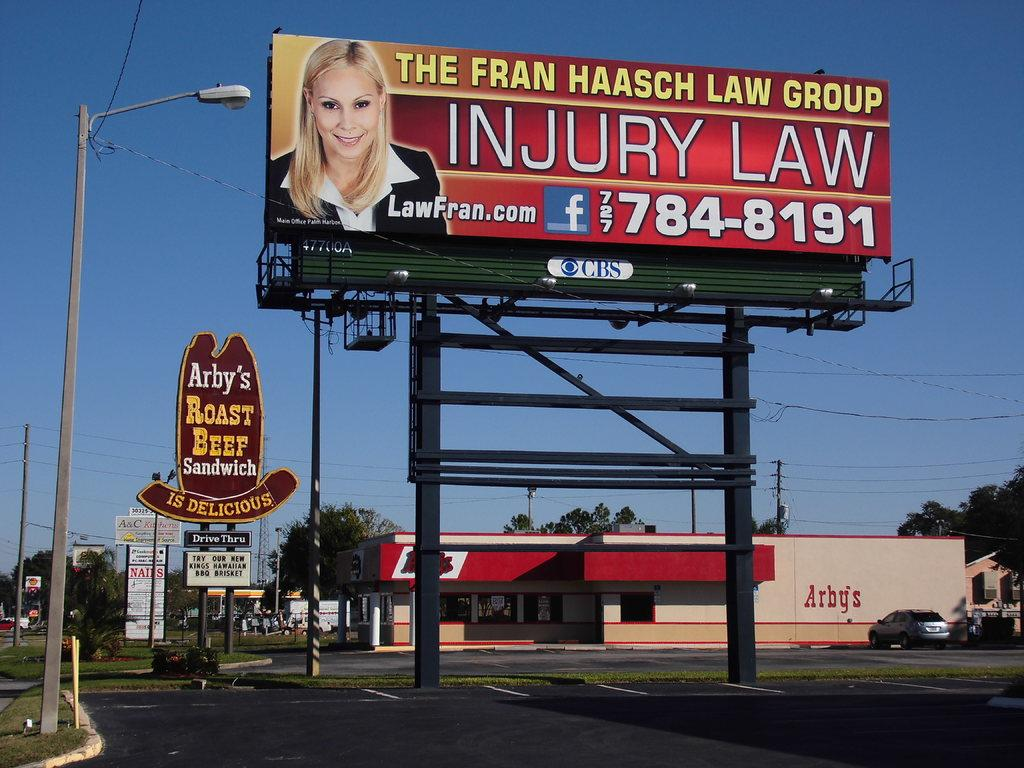<image>
Share a concise interpretation of the image provided. a billboard with a Arby's sign behind it 